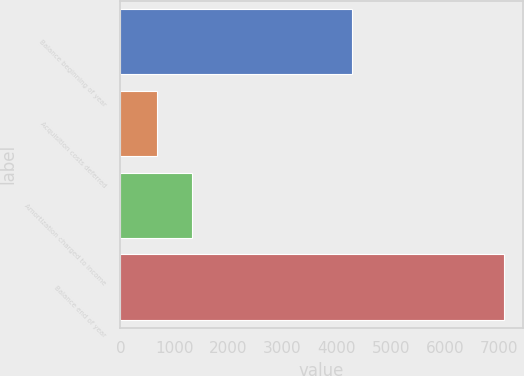Convert chart. <chart><loc_0><loc_0><loc_500><loc_500><bar_chart><fcel>Balance beginning of year<fcel>Acquisition costs deferred<fcel>Amortization charged to income<fcel>Balance end of year<nl><fcel>4291<fcel>684<fcel>1324.5<fcel>7089<nl></chart> 